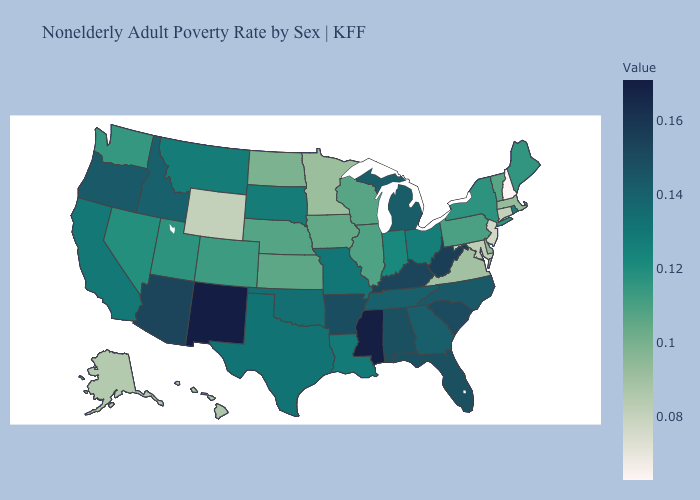Which states have the highest value in the USA?
Keep it brief. New Mexico. Among the states that border Wisconsin , does Michigan have the highest value?
Keep it brief. Yes. Which states have the lowest value in the USA?
Quick response, please. New Hampshire. Among the states that border Kentucky , does Missouri have the highest value?
Quick response, please. No. Which states have the highest value in the USA?
Short answer required. New Mexico. Does West Virginia have a lower value than New Mexico?
Answer briefly. Yes. Which states have the lowest value in the USA?
Short answer required. New Hampshire. 